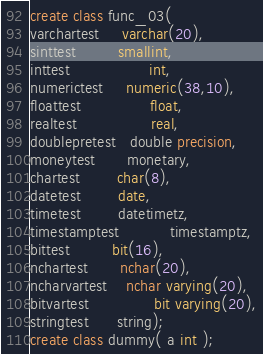<code> <loc_0><loc_0><loc_500><loc_500><_SQL_>
create class func_03(
varchartest     varchar(20),
sinttest         smallint,
inttest                 int,
numerictest     numeric(38,10),
floattest               float,
realtest                real,
doublepretest   double precision,
moneytest       monetary,
chartest        char(8),
datetest        date,
timetest        datetimetz,
timestamptest           timestamptz,
bittest         bit(16),
nchartest       nchar(20),
ncharvartest    nchar varying(20),
bitvartest              bit varying(20),
stringtest      string);
create class dummy( a int );</code> 